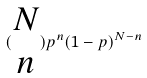Convert formula to latex. <formula><loc_0><loc_0><loc_500><loc_500>( \begin{matrix} N \\ n \end{matrix} ) p ^ { n } ( 1 - p ) ^ { N - n }</formula> 